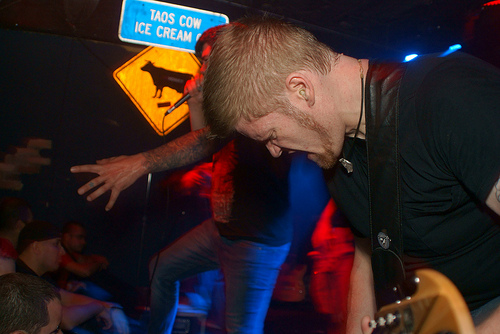<image>
Is the sign behind the singer? Yes. From this viewpoint, the sign is positioned behind the singer, with the singer partially or fully occluding the sign. 